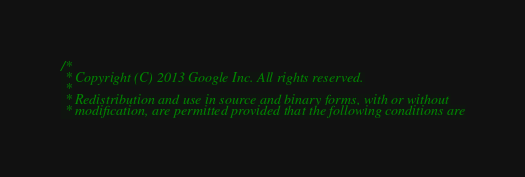<code> <loc_0><loc_0><loc_500><loc_500><_C_>/*
 * Copyright (C) 2013 Google Inc. All rights reserved.
 *
 * Redistribution and use in source and binary forms, with or without
 * modification, are permitted provided that the following conditions are</code> 